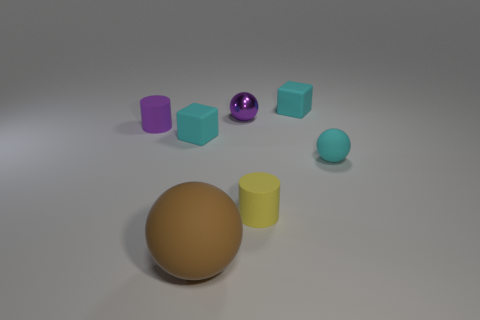Subtract all tiny purple shiny spheres. How many spheres are left? 2 Subtract all purple cylinders. How many cylinders are left? 1 Subtract 1 spheres. How many spheres are left? 2 Subtract all cubes. How many objects are left? 5 Add 1 purple balls. How many objects exist? 8 Subtract 0 red cylinders. How many objects are left? 7 Subtract all purple cylinders. Subtract all red cubes. How many cylinders are left? 1 Subtract all cyan balls. How many gray cylinders are left? 0 Subtract all tiny gray shiny cubes. Subtract all purple metal things. How many objects are left? 6 Add 1 small matte cylinders. How many small matte cylinders are left? 3 